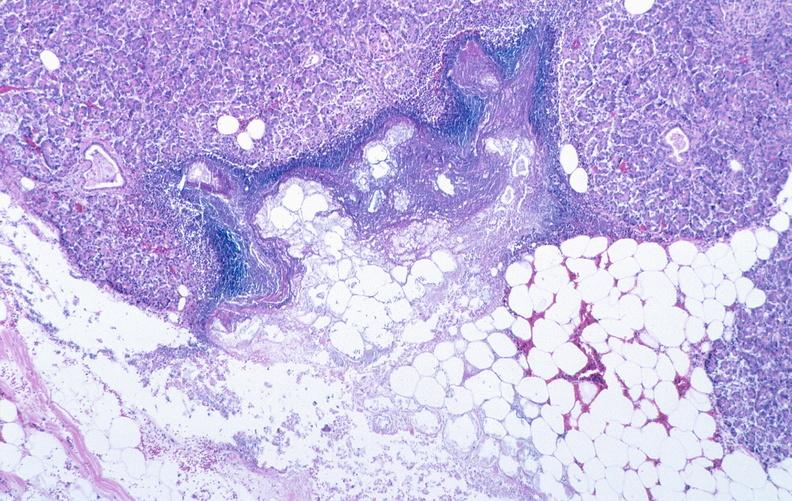where is this?
Answer the question using a single word or phrase. Pancreas 